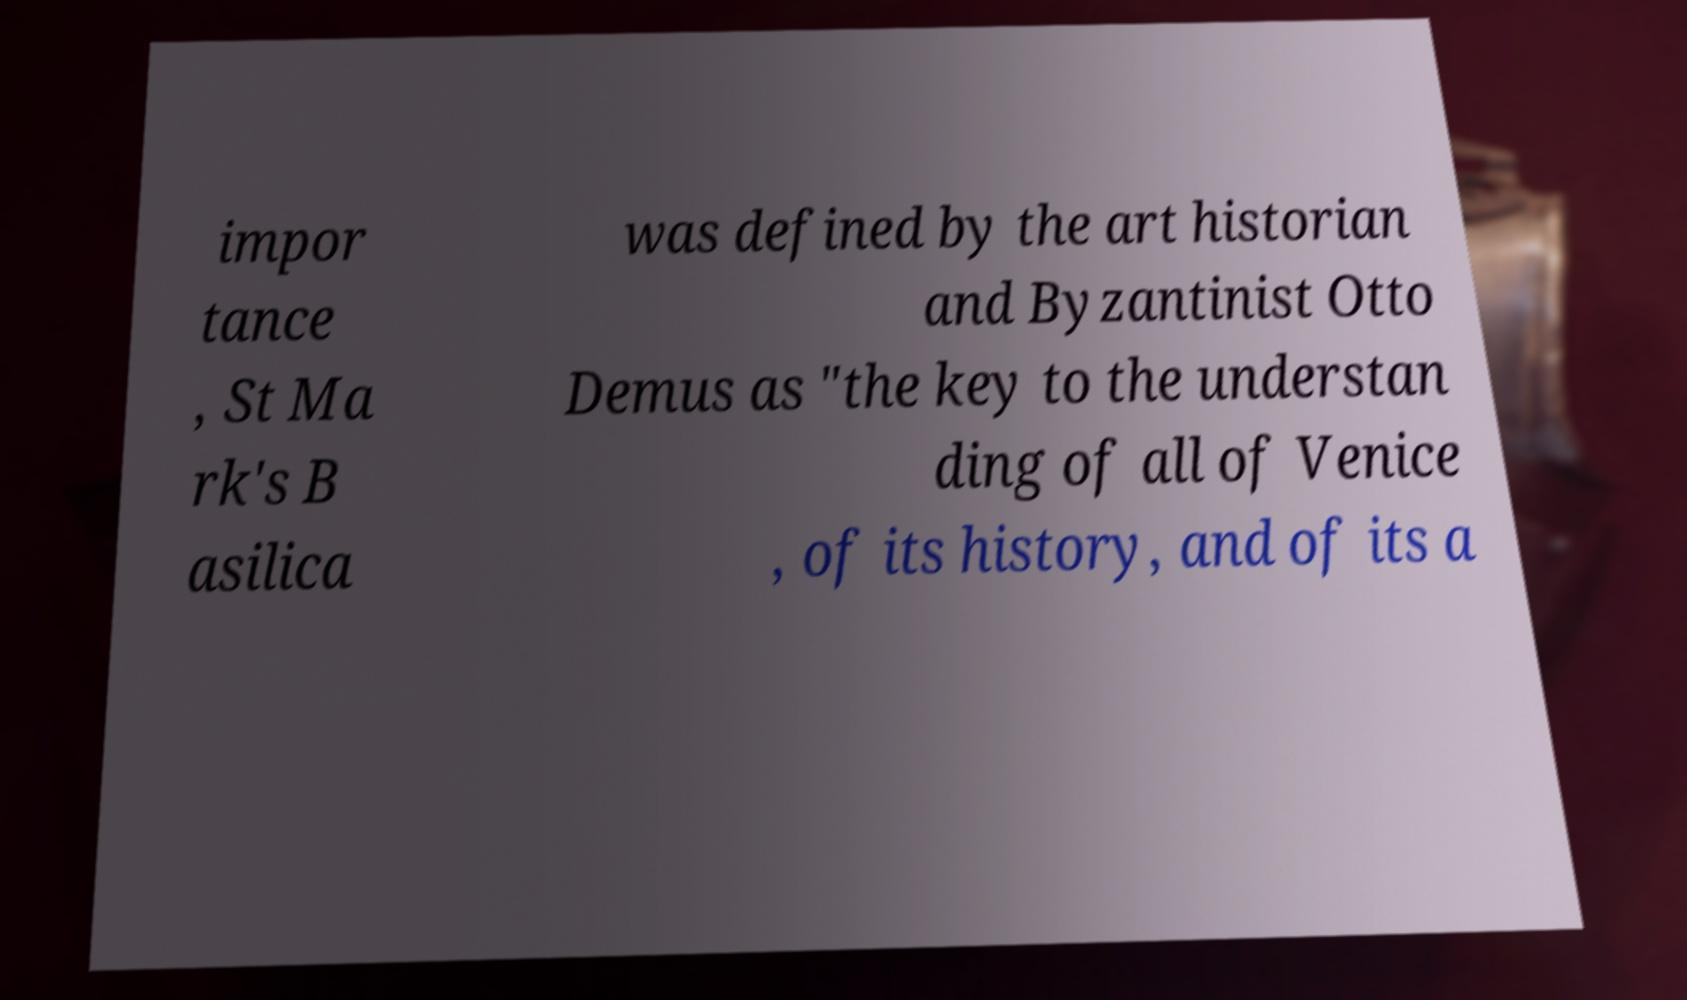Can you read and provide the text displayed in the image?This photo seems to have some interesting text. Can you extract and type it out for me? impor tance , St Ma rk's B asilica was defined by the art historian and Byzantinist Otto Demus as "the key to the understan ding of all of Venice , of its history, and of its a 